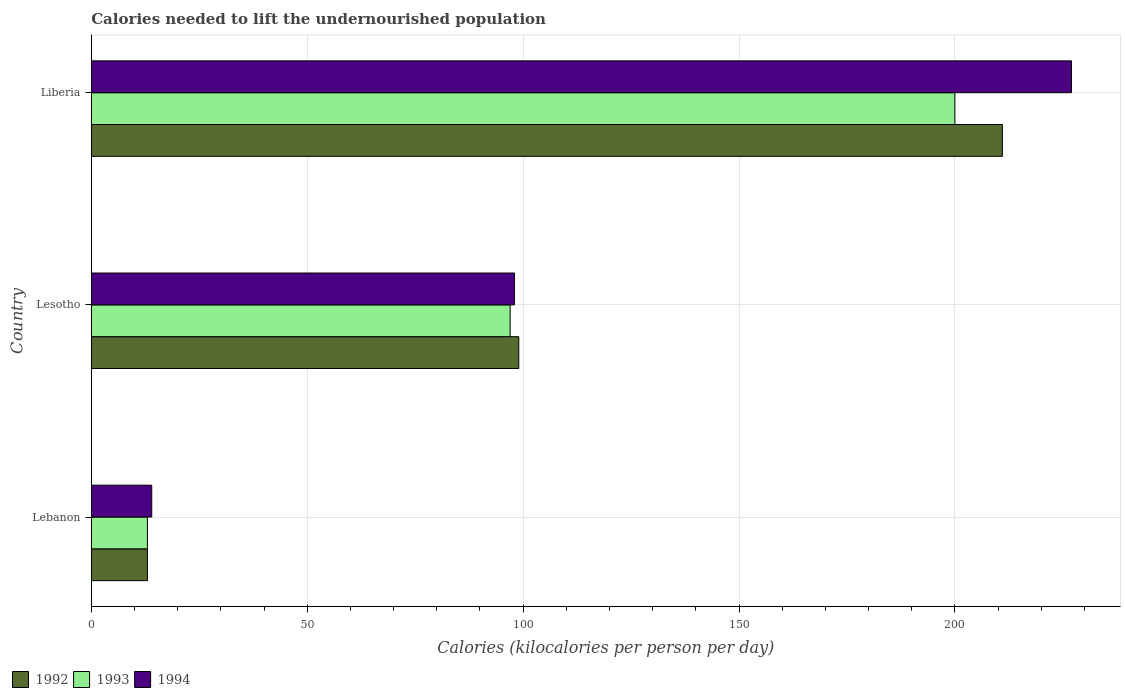How many different coloured bars are there?
Give a very brief answer. 3. Are the number of bars per tick equal to the number of legend labels?
Ensure brevity in your answer.  Yes. Are the number of bars on each tick of the Y-axis equal?
Make the answer very short. Yes. What is the label of the 3rd group of bars from the top?
Your answer should be very brief. Lebanon. In how many cases, is the number of bars for a given country not equal to the number of legend labels?
Keep it short and to the point. 0. Across all countries, what is the maximum total calories needed to lift the undernourished population in 1994?
Give a very brief answer. 227. Across all countries, what is the minimum total calories needed to lift the undernourished population in 1993?
Your answer should be compact. 13. In which country was the total calories needed to lift the undernourished population in 1992 maximum?
Offer a terse response. Liberia. In which country was the total calories needed to lift the undernourished population in 1993 minimum?
Your answer should be compact. Lebanon. What is the total total calories needed to lift the undernourished population in 1992 in the graph?
Your response must be concise. 323. What is the difference between the total calories needed to lift the undernourished population in 1992 in Lebanon and that in Liberia?
Your answer should be compact. -198. What is the difference between the total calories needed to lift the undernourished population in 1993 in Lesotho and the total calories needed to lift the undernourished population in 1994 in Lebanon?
Offer a terse response. 83. What is the average total calories needed to lift the undernourished population in 1992 per country?
Make the answer very short. 107.67. What is the ratio of the total calories needed to lift the undernourished population in 1992 in Lebanon to that in Lesotho?
Ensure brevity in your answer.  0.13. Is the total calories needed to lift the undernourished population in 1994 in Lebanon less than that in Liberia?
Keep it short and to the point. Yes. Is the difference between the total calories needed to lift the undernourished population in 1994 in Lesotho and Liberia greater than the difference between the total calories needed to lift the undernourished population in 1993 in Lesotho and Liberia?
Your response must be concise. No. What is the difference between the highest and the second highest total calories needed to lift the undernourished population in 1993?
Give a very brief answer. 103. What is the difference between the highest and the lowest total calories needed to lift the undernourished population in 1994?
Provide a short and direct response. 213. Are all the bars in the graph horizontal?
Ensure brevity in your answer.  Yes. How many countries are there in the graph?
Make the answer very short. 3. Does the graph contain any zero values?
Give a very brief answer. No. Does the graph contain grids?
Make the answer very short. Yes. How many legend labels are there?
Make the answer very short. 3. How are the legend labels stacked?
Ensure brevity in your answer.  Horizontal. What is the title of the graph?
Provide a succinct answer. Calories needed to lift the undernourished population. Does "2011" appear as one of the legend labels in the graph?
Your answer should be very brief. No. What is the label or title of the X-axis?
Your response must be concise. Calories (kilocalories per person per day). What is the label or title of the Y-axis?
Provide a succinct answer. Country. What is the Calories (kilocalories per person per day) in 1992 in Lebanon?
Provide a succinct answer. 13. What is the Calories (kilocalories per person per day) of 1992 in Lesotho?
Your answer should be very brief. 99. What is the Calories (kilocalories per person per day) in 1993 in Lesotho?
Your response must be concise. 97. What is the Calories (kilocalories per person per day) of 1994 in Lesotho?
Keep it short and to the point. 98. What is the Calories (kilocalories per person per day) in 1992 in Liberia?
Provide a succinct answer. 211. What is the Calories (kilocalories per person per day) of 1994 in Liberia?
Keep it short and to the point. 227. Across all countries, what is the maximum Calories (kilocalories per person per day) in 1992?
Provide a short and direct response. 211. Across all countries, what is the maximum Calories (kilocalories per person per day) in 1993?
Keep it short and to the point. 200. Across all countries, what is the maximum Calories (kilocalories per person per day) in 1994?
Provide a short and direct response. 227. Across all countries, what is the minimum Calories (kilocalories per person per day) of 1993?
Keep it short and to the point. 13. What is the total Calories (kilocalories per person per day) of 1992 in the graph?
Your response must be concise. 323. What is the total Calories (kilocalories per person per day) of 1993 in the graph?
Offer a terse response. 310. What is the total Calories (kilocalories per person per day) of 1994 in the graph?
Provide a succinct answer. 339. What is the difference between the Calories (kilocalories per person per day) of 1992 in Lebanon and that in Lesotho?
Make the answer very short. -86. What is the difference between the Calories (kilocalories per person per day) of 1993 in Lebanon and that in Lesotho?
Keep it short and to the point. -84. What is the difference between the Calories (kilocalories per person per day) in 1994 in Lebanon and that in Lesotho?
Provide a succinct answer. -84. What is the difference between the Calories (kilocalories per person per day) of 1992 in Lebanon and that in Liberia?
Your answer should be very brief. -198. What is the difference between the Calories (kilocalories per person per day) in 1993 in Lebanon and that in Liberia?
Offer a terse response. -187. What is the difference between the Calories (kilocalories per person per day) in 1994 in Lebanon and that in Liberia?
Ensure brevity in your answer.  -213. What is the difference between the Calories (kilocalories per person per day) in 1992 in Lesotho and that in Liberia?
Keep it short and to the point. -112. What is the difference between the Calories (kilocalories per person per day) in 1993 in Lesotho and that in Liberia?
Your response must be concise. -103. What is the difference between the Calories (kilocalories per person per day) in 1994 in Lesotho and that in Liberia?
Give a very brief answer. -129. What is the difference between the Calories (kilocalories per person per day) of 1992 in Lebanon and the Calories (kilocalories per person per day) of 1993 in Lesotho?
Give a very brief answer. -84. What is the difference between the Calories (kilocalories per person per day) in 1992 in Lebanon and the Calories (kilocalories per person per day) in 1994 in Lesotho?
Give a very brief answer. -85. What is the difference between the Calories (kilocalories per person per day) of 1993 in Lebanon and the Calories (kilocalories per person per day) of 1994 in Lesotho?
Your answer should be compact. -85. What is the difference between the Calories (kilocalories per person per day) in 1992 in Lebanon and the Calories (kilocalories per person per day) in 1993 in Liberia?
Keep it short and to the point. -187. What is the difference between the Calories (kilocalories per person per day) of 1992 in Lebanon and the Calories (kilocalories per person per day) of 1994 in Liberia?
Ensure brevity in your answer.  -214. What is the difference between the Calories (kilocalories per person per day) in 1993 in Lebanon and the Calories (kilocalories per person per day) in 1994 in Liberia?
Provide a short and direct response. -214. What is the difference between the Calories (kilocalories per person per day) of 1992 in Lesotho and the Calories (kilocalories per person per day) of 1993 in Liberia?
Provide a succinct answer. -101. What is the difference between the Calories (kilocalories per person per day) of 1992 in Lesotho and the Calories (kilocalories per person per day) of 1994 in Liberia?
Your answer should be compact. -128. What is the difference between the Calories (kilocalories per person per day) of 1993 in Lesotho and the Calories (kilocalories per person per day) of 1994 in Liberia?
Ensure brevity in your answer.  -130. What is the average Calories (kilocalories per person per day) in 1992 per country?
Make the answer very short. 107.67. What is the average Calories (kilocalories per person per day) in 1993 per country?
Offer a very short reply. 103.33. What is the average Calories (kilocalories per person per day) in 1994 per country?
Offer a terse response. 113. What is the difference between the Calories (kilocalories per person per day) in 1992 and Calories (kilocalories per person per day) in 1993 in Lebanon?
Offer a very short reply. 0. What is the difference between the Calories (kilocalories per person per day) in 1993 and Calories (kilocalories per person per day) in 1994 in Lebanon?
Offer a terse response. -1. What is the difference between the Calories (kilocalories per person per day) of 1993 and Calories (kilocalories per person per day) of 1994 in Lesotho?
Provide a succinct answer. -1. What is the difference between the Calories (kilocalories per person per day) in 1993 and Calories (kilocalories per person per day) in 1994 in Liberia?
Ensure brevity in your answer.  -27. What is the ratio of the Calories (kilocalories per person per day) of 1992 in Lebanon to that in Lesotho?
Make the answer very short. 0.13. What is the ratio of the Calories (kilocalories per person per day) of 1993 in Lebanon to that in Lesotho?
Keep it short and to the point. 0.13. What is the ratio of the Calories (kilocalories per person per day) in 1994 in Lebanon to that in Lesotho?
Offer a very short reply. 0.14. What is the ratio of the Calories (kilocalories per person per day) in 1992 in Lebanon to that in Liberia?
Make the answer very short. 0.06. What is the ratio of the Calories (kilocalories per person per day) of 1993 in Lebanon to that in Liberia?
Make the answer very short. 0.07. What is the ratio of the Calories (kilocalories per person per day) of 1994 in Lebanon to that in Liberia?
Offer a terse response. 0.06. What is the ratio of the Calories (kilocalories per person per day) of 1992 in Lesotho to that in Liberia?
Make the answer very short. 0.47. What is the ratio of the Calories (kilocalories per person per day) of 1993 in Lesotho to that in Liberia?
Give a very brief answer. 0.48. What is the ratio of the Calories (kilocalories per person per day) of 1994 in Lesotho to that in Liberia?
Your answer should be compact. 0.43. What is the difference between the highest and the second highest Calories (kilocalories per person per day) of 1992?
Your answer should be compact. 112. What is the difference between the highest and the second highest Calories (kilocalories per person per day) in 1993?
Your answer should be compact. 103. What is the difference between the highest and the second highest Calories (kilocalories per person per day) in 1994?
Your answer should be very brief. 129. What is the difference between the highest and the lowest Calories (kilocalories per person per day) in 1992?
Give a very brief answer. 198. What is the difference between the highest and the lowest Calories (kilocalories per person per day) of 1993?
Provide a succinct answer. 187. What is the difference between the highest and the lowest Calories (kilocalories per person per day) in 1994?
Ensure brevity in your answer.  213. 